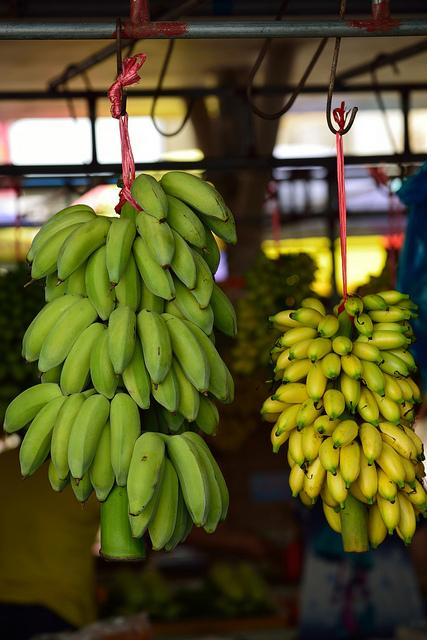Where are these items sold?

Choices:
A) shoprite
B) hobby lobby
C) home depot
D) best buy shoprite 